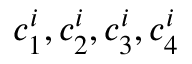<formula> <loc_0><loc_0><loc_500><loc_500>c _ { 1 } ^ { i } , c _ { 2 } ^ { i } , c _ { 3 } ^ { i } , c _ { 4 } ^ { i }</formula> 